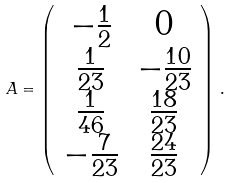<formula> <loc_0><loc_0><loc_500><loc_500>A = \left ( \begin{array} { c c c } - \frac { 1 } { 2 } & 0 \\ \frac { 1 } { 2 3 } & - \frac { 1 0 } { 2 3 } \\ \frac { 1 } { 4 6 } & \frac { 1 8 } { 2 3 } \\ - \frac { 7 } { 2 3 } & \frac { 2 4 } { 2 3 } \end{array} \right ) \, .</formula> 